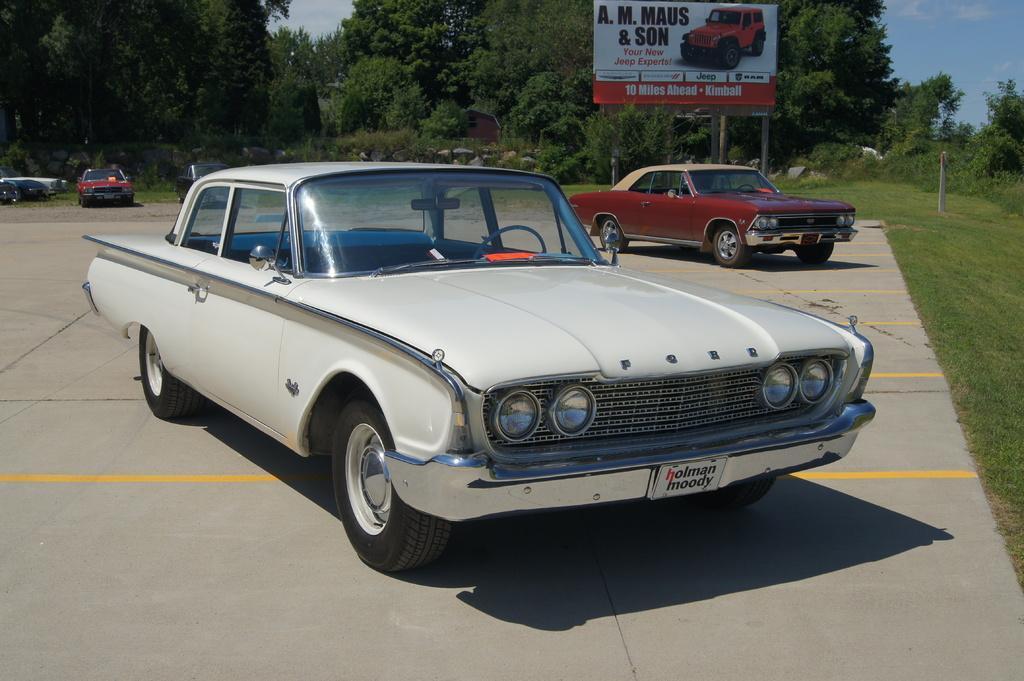How would you summarize this image in a sentence or two? In this image I can see fleets of cars on the road and grass. In the background I can see a fence, board, trees and the sky. This image is taken may be on the road. 